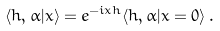<formula> <loc_0><loc_0><loc_500><loc_500>\langle h , \alpha | x \rangle = e ^ { - i x h } \langle h , \alpha | x = 0 \rangle \, .</formula> 